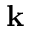Convert formula to latex. <formula><loc_0><loc_0><loc_500><loc_500>k</formula> 